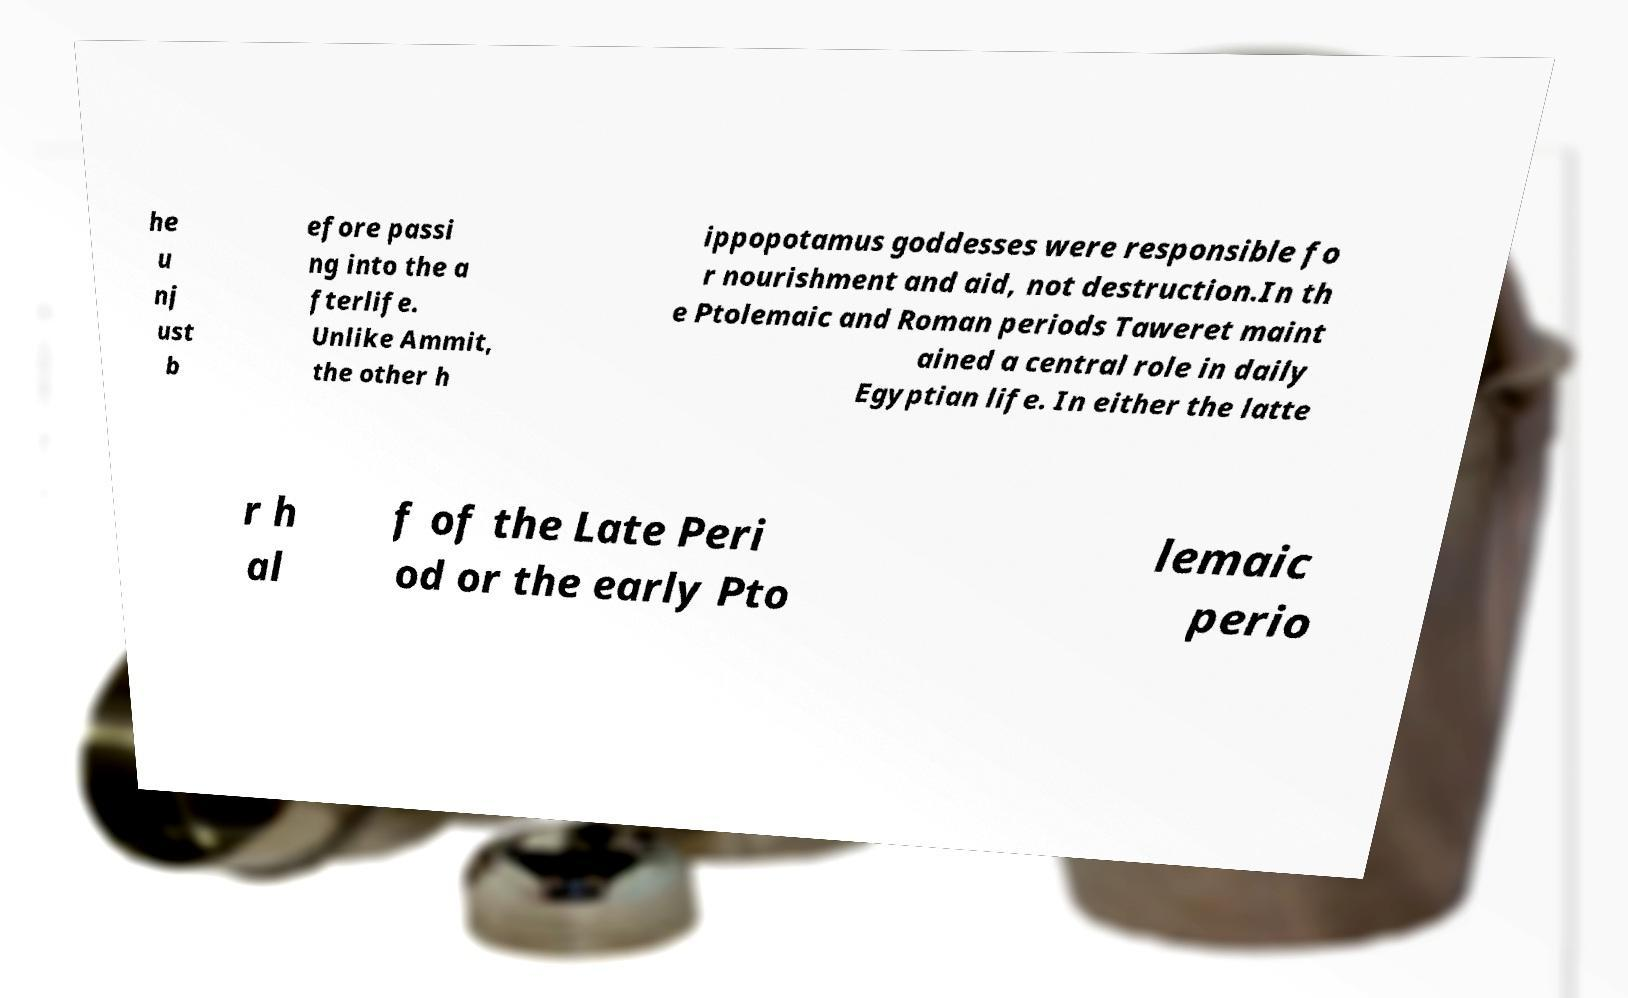Can you accurately transcribe the text from the provided image for me? he u nj ust b efore passi ng into the a fterlife. Unlike Ammit, the other h ippopotamus goddesses were responsible fo r nourishment and aid, not destruction.In th e Ptolemaic and Roman periods Taweret maint ained a central role in daily Egyptian life. In either the latte r h al f of the Late Peri od or the early Pto lemaic perio 